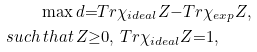<formula> <loc_0><loc_0><loc_500><loc_500>\max \, & d { = } T r \chi _ { i d e a l } Z { - } T r \chi _ { e x p } Z , \\ s u c h \, t h a t \, & Z { \geq } 0 , \, T r \chi _ { i d e a l } Z { = } 1 ,</formula> 